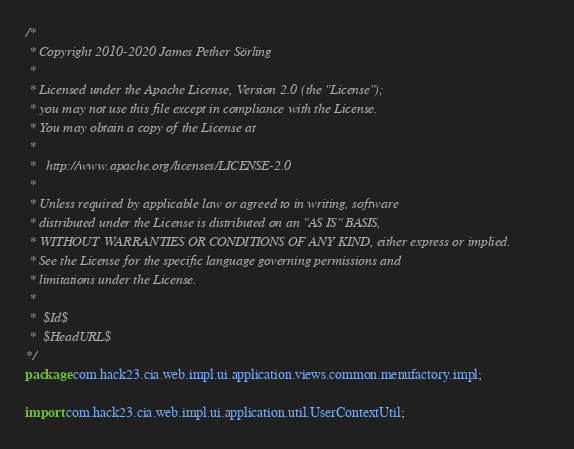<code> <loc_0><loc_0><loc_500><loc_500><_Java_>/*
 * Copyright 2010-2020 James Pether Sörling
 *
 * Licensed under the Apache License, Version 2.0 (the "License");
 * you may not use this file except in compliance with the License.
 * You may obtain a copy of the License at
 *
 *   http://www.apache.org/licenses/LICENSE-2.0
 *
 * Unless required by applicable law or agreed to in writing, software
 * distributed under the License is distributed on an "AS IS" BASIS,
 * WITHOUT WARRANTIES OR CONDITIONS OF ANY KIND, either express or implied.
 * See the License for the specific language governing permissions and
 * limitations under the License.
 *
 *	$Id$
 *  $HeadURL$
*/
package com.hack23.cia.web.impl.ui.application.views.common.menufactory.impl;

import com.hack23.cia.web.impl.ui.application.util.UserContextUtil;</code> 